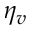Convert formula to latex. <formula><loc_0><loc_0><loc_500><loc_500>\eta _ { v }</formula> 